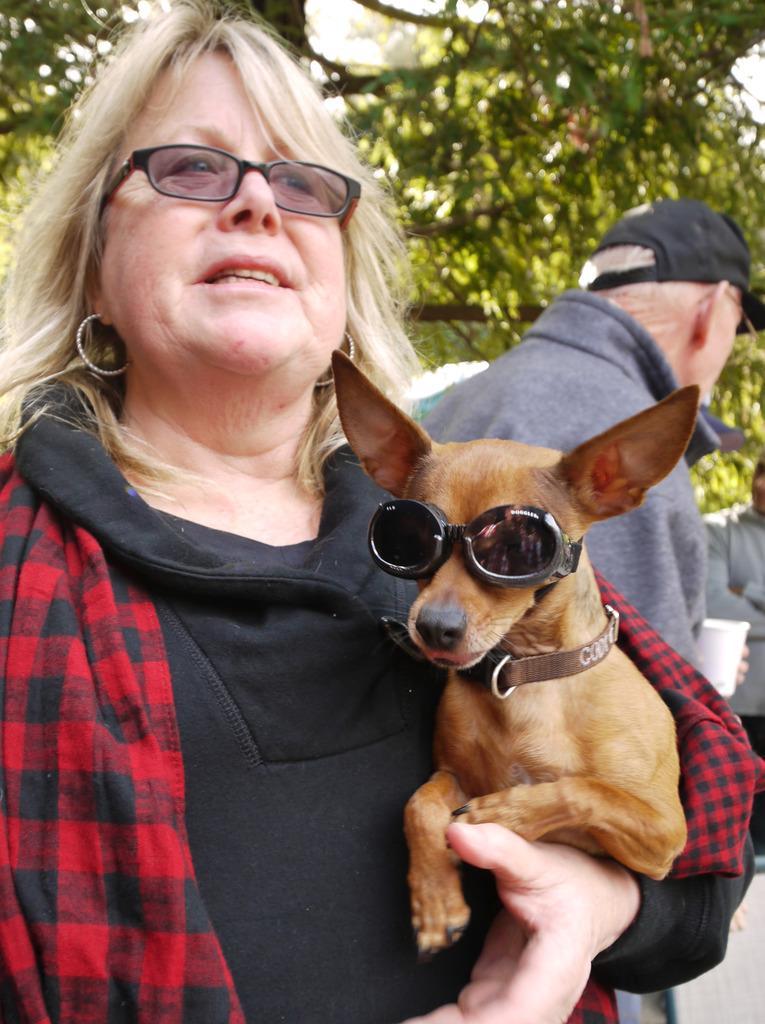Please provide a concise description of this image. In this image there is a man and woman. Woman who is wearing a spectacles and red color jacket holding a puppy which has leash and black color goggles and at the right side of the image the man holding a coffee glass wearing a black color cap and at the top of the image there are trees 